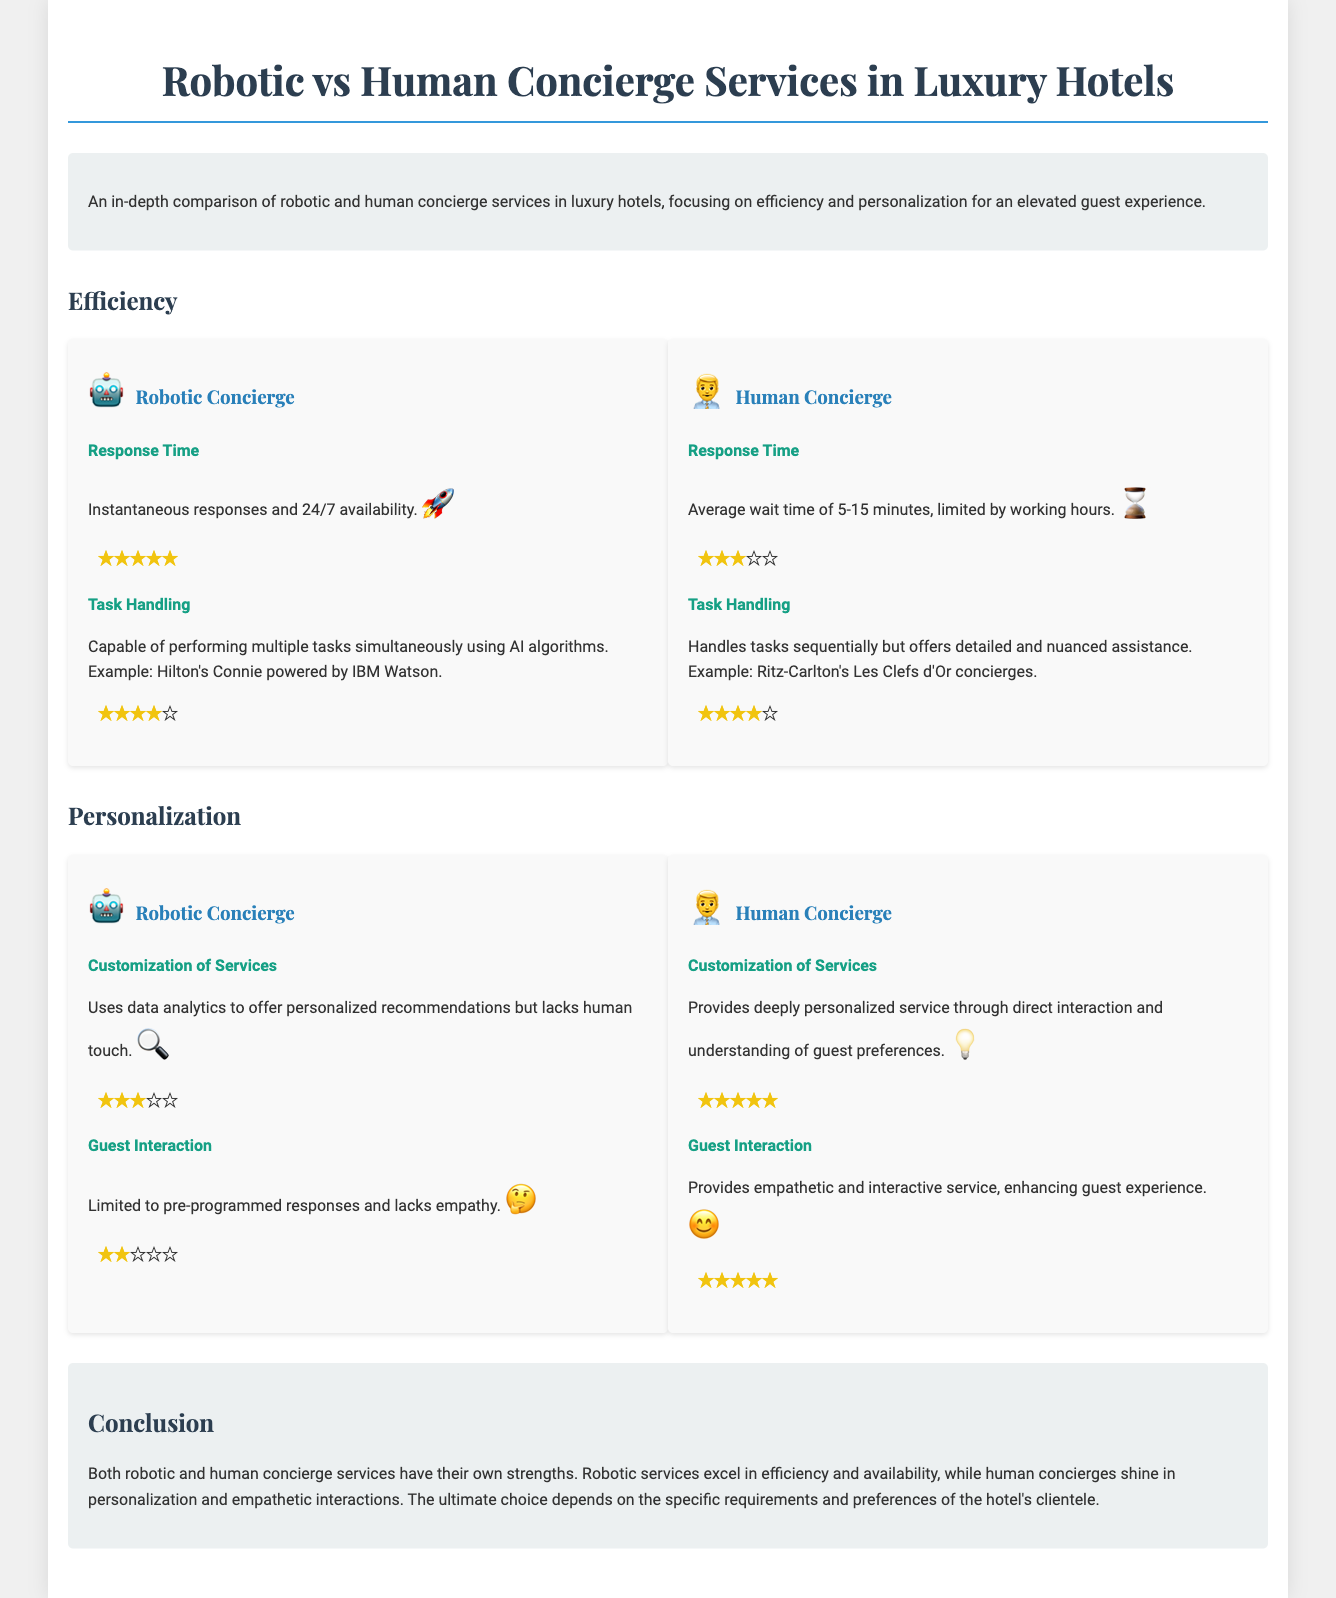What is the response time for robotic concierge services? The response time for robotic concierge services is instantaneous and 24/7 available.
Answer: Instantaneous What is the average wait time for human concierge services? The average wait time for human concierge services is mentioned as 5-15 minutes.
Answer: 5-15 minutes What are the ratings for robotic concierge in task handling? The robotic concierge has a rating of four stars and one half star in task handling.
Answer: Four stars and one half star What example is given for human concierge services? The example given for human concierge services is Ritz-Carlton's Les Clefs d'Or concierges.
Answer: Ritz-Carlton's Les Clefs d'Or How does robotic concierge handle customization of services? Robotic concierge uses data analytics to offer personalized recommendations, lacking human touch.
Answer: Uses data analytics What is the guest interaction rating for human concierges? The guest interaction rating for human concierges is five stars.
Answer: Five stars What is a key strength of robotic concierge services? A key strength of robotic concierge services is their efficiency and availability.
Answer: Efficiency and availability What is emphasized in the conclusion about human concierges? The conclusion emphasizes that human concierges shine in personalization and empathetic interactions.
Answer: Personalization and empathetic interactions What technology powers Hilton's concierge robot? The technology that powers Hilton's concierge robot is IBM Watson.
Answer: IBM Watson 